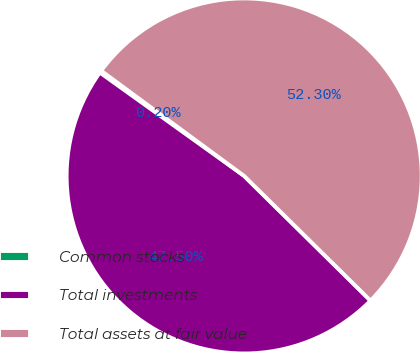Convert chart. <chart><loc_0><loc_0><loc_500><loc_500><pie_chart><fcel>Common stocks<fcel>Total investments<fcel>Total assets at fair value<nl><fcel>0.2%<fcel>47.5%<fcel>52.3%<nl></chart> 